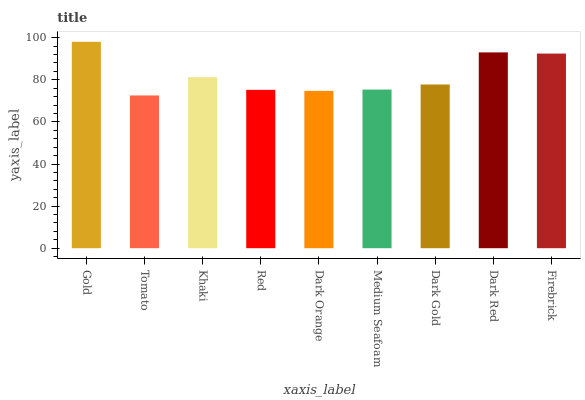Is Tomato the minimum?
Answer yes or no. Yes. Is Gold the maximum?
Answer yes or no. Yes. Is Khaki the minimum?
Answer yes or no. No. Is Khaki the maximum?
Answer yes or no. No. Is Khaki greater than Tomato?
Answer yes or no. Yes. Is Tomato less than Khaki?
Answer yes or no. Yes. Is Tomato greater than Khaki?
Answer yes or no. No. Is Khaki less than Tomato?
Answer yes or no. No. Is Dark Gold the high median?
Answer yes or no. Yes. Is Dark Gold the low median?
Answer yes or no. Yes. Is Khaki the high median?
Answer yes or no. No. Is Red the low median?
Answer yes or no. No. 